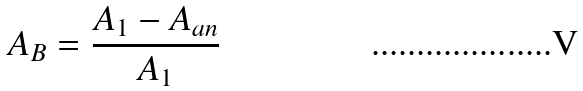Convert formula to latex. <formula><loc_0><loc_0><loc_500><loc_500>A _ { B } = \frac { A _ { 1 } - A _ { a n } } { A _ { 1 } }</formula> 